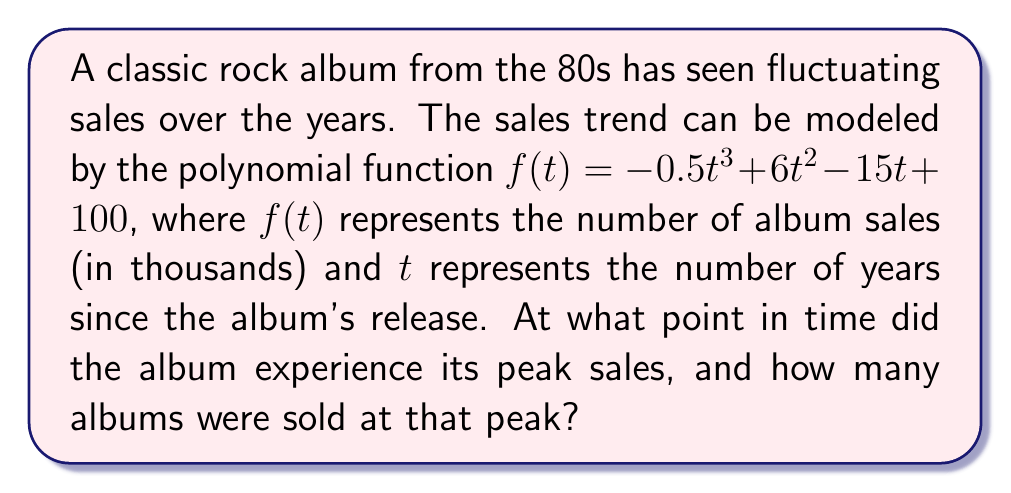Could you help me with this problem? To find the peak sales, we need to determine the maximum point of the polynomial function. This occurs where the derivative of the function is zero.

Step 1: Find the derivative of $f(t)$
$$f'(t) = -1.5t^2 + 12t - 15$$

Step 2: Set the derivative equal to zero and solve for $t$
$$-1.5t^2 + 12t - 15 = 0$$

Step 3: Use the quadratic formula to solve this equation
$$t = \frac{-b \pm \sqrt{b^2 - 4ac}}{2a}$$
Where $a = -1.5$, $b = 12$, and $c = -15$

$$t = \frac{-12 \pm \sqrt{12^2 - 4(-1.5)(-15)}}{2(-1.5)}$$
$$t = \frac{-12 \pm \sqrt{144 - 90}}{-3}$$
$$t = \frac{-12 \pm \sqrt{54}}{-3}$$
$$t = \frac{-12 \pm 3\sqrt{6}}{-3}$$

Step 4: Simplify and solve
$$t_1 = \frac{-12 + 3\sqrt{6}}{-3} = 4 - \sqrt{6}$$
$$t_2 = \frac{-12 - 3\sqrt{6}}{-3} = 4 + \sqrt{6}$$

Step 5: Determine which solution gives the maximum
Since the coefficient of $t^3$ in the original function is negative, the function opens downward, so the larger $t$ value (4 + √6) gives the maximum.

Step 6: Calculate the peak sales by plugging $t = 4 + \sqrt{6}$ into the original function
$$f(4 + \sqrt{6}) = -0.5(4 + \sqrt{6})^3 + 6(4 + \sqrt{6})^2 - 15(4 + \sqrt{6}) + 100$$

Using a calculator to evaluate this expression, we get approximately 114.7 thousand album sales.

Therefore, the album experienced its peak sales after approximately 6.45 years (4 + √6 ≈ 6.45), with about 114.7 thousand albums sold at that peak.
Answer: 6.45 years after release; 114.7 thousand albums 